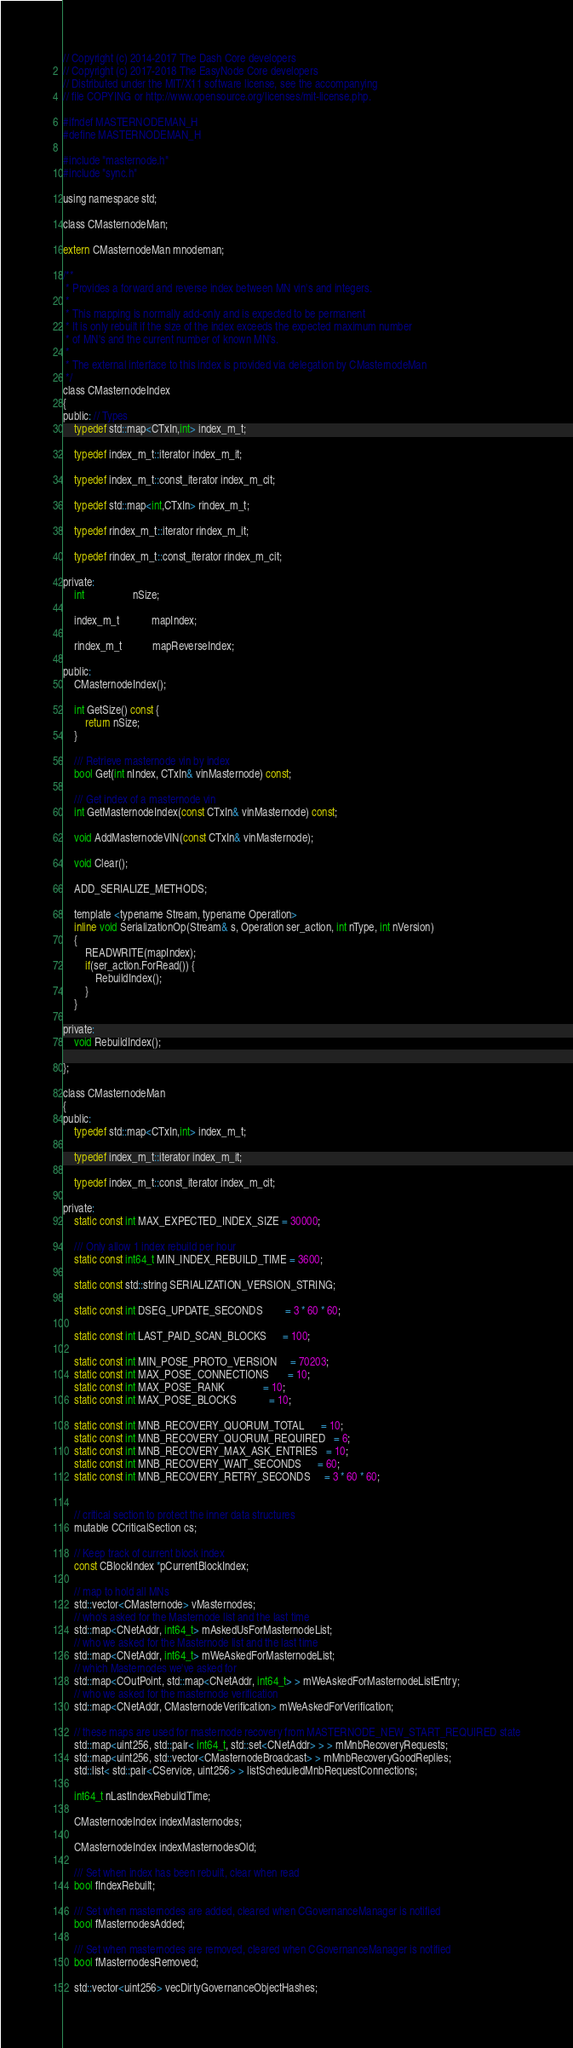Convert code to text. <code><loc_0><loc_0><loc_500><loc_500><_C_>// Copyright (c) 2014-2017 The Dash Core developers
// Copyright (c) 2017-2018 The EasyNode Core developers
// Distributed under the MIT/X11 software license, see the accompanying
// file COPYING or http://www.opensource.org/licenses/mit-license.php.

#ifndef MASTERNODEMAN_H
#define MASTERNODEMAN_H

#include "masternode.h"
#include "sync.h"

using namespace std;

class CMasternodeMan;

extern CMasternodeMan mnodeman;

/**
 * Provides a forward and reverse index between MN vin's and integers.
 *
 * This mapping is normally add-only and is expected to be permanent
 * It is only rebuilt if the size of the index exceeds the expected maximum number
 * of MN's and the current number of known MN's.
 *
 * The external interface to this index is provided via delegation by CMasternodeMan
 */
class CMasternodeIndex
{
public: // Types
    typedef std::map<CTxIn,int> index_m_t;

    typedef index_m_t::iterator index_m_it;

    typedef index_m_t::const_iterator index_m_cit;

    typedef std::map<int,CTxIn> rindex_m_t;

    typedef rindex_m_t::iterator rindex_m_it;

    typedef rindex_m_t::const_iterator rindex_m_cit;

private:
    int                  nSize;

    index_m_t            mapIndex;

    rindex_m_t           mapReverseIndex;

public:
    CMasternodeIndex();

    int GetSize() const {
        return nSize;
    }

    /// Retrieve masternode vin by index
    bool Get(int nIndex, CTxIn& vinMasternode) const;

    /// Get index of a masternode vin
    int GetMasternodeIndex(const CTxIn& vinMasternode) const;

    void AddMasternodeVIN(const CTxIn& vinMasternode);

    void Clear();

    ADD_SERIALIZE_METHODS;

    template <typename Stream, typename Operation>
    inline void SerializationOp(Stream& s, Operation ser_action, int nType, int nVersion)
    {
        READWRITE(mapIndex);
        if(ser_action.ForRead()) {
            RebuildIndex();
        }
    }

private:
    void RebuildIndex();

};

class CMasternodeMan
{
public:
    typedef std::map<CTxIn,int> index_m_t;

    typedef index_m_t::iterator index_m_it;

    typedef index_m_t::const_iterator index_m_cit;

private:
    static const int MAX_EXPECTED_INDEX_SIZE = 30000;

    /// Only allow 1 index rebuild per hour
    static const int64_t MIN_INDEX_REBUILD_TIME = 3600;

    static const std::string SERIALIZATION_VERSION_STRING;

    static const int DSEG_UPDATE_SECONDS        = 3 * 60 * 60;

    static const int LAST_PAID_SCAN_BLOCKS      = 100;

    static const int MIN_POSE_PROTO_VERSION     = 70203;
    static const int MAX_POSE_CONNECTIONS       = 10;
    static const int MAX_POSE_RANK              = 10;
    static const int MAX_POSE_BLOCKS            = 10;

    static const int MNB_RECOVERY_QUORUM_TOTAL      = 10;
    static const int MNB_RECOVERY_QUORUM_REQUIRED   = 6;
    static const int MNB_RECOVERY_MAX_ASK_ENTRIES   = 10;
    static const int MNB_RECOVERY_WAIT_SECONDS      = 60;
    static const int MNB_RECOVERY_RETRY_SECONDS     = 3 * 60 * 60;


    // critical section to protect the inner data structures
    mutable CCriticalSection cs;

    // Keep track of current block index
    const CBlockIndex *pCurrentBlockIndex;

    // map to hold all MNs
    std::vector<CMasternode> vMasternodes;
    // who's asked for the Masternode list and the last time
    std::map<CNetAddr, int64_t> mAskedUsForMasternodeList;
    // who we asked for the Masternode list and the last time
    std::map<CNetAddr, int64_t> mWeAskedForMasternodeList;
    // which Masternodes we've asked for
    std::map<COutPoint, std::map<CNetAddr, int64_t> > mWeAskedForMasternodeListEntry;
    // who we asked for the masternode verification
    std::map<CNetAddr, CMasternodeVerification> mWeAskedForVerification;

    // these maps are used for masternode recovery from MASTERNODE_NEW_START_REQUIRED state
    std::map<uint256, std::pair< int64_t, std::set<CNetAddr> > > mMnbRecoveryRequests;
    std::map<uint256, std::vector<CMasternodeBroadcast> > mMnbRecoveryGoodReplies;
    std::list< std::pair<CService, uint256> > listScheduledMnbRequestConnections;

    int64_t nLastIndexRebuildTime;

    CMasternodeIndex indexMasternodes;

    CMasternodeIndex indexMasternodesOld;

    /// Set when index has been rebuilt, clear when read
    bool fIndexRebuilt;

    /// Set when masternodes are added, cleared when CGovernanceManager is notified
    bool fMasternodesAdded;

    /// Set when masternodes are removed, cleared when CGovernanceManager is notified
    bool fMasternodesRemoved;

    std::vector<uint256> vecDirtyGovernanceObjectHashes;
</code> 